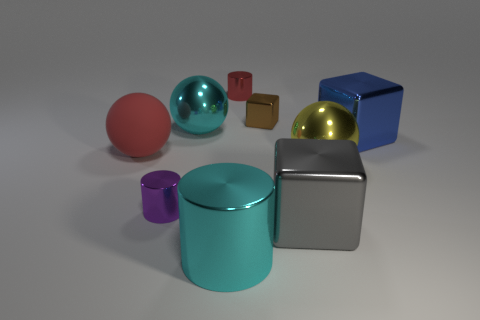Is there any other thing that has the same material as the large red sphere?
Provide a succinct answer. No. Are there fewer tiny objects that are in front of the tiny red cylinder than metallic objects in front of the yellow object?
Make the answer very short. Yes. What shape is the big metal thing that is both behind the purple cylinder and in front of the large red matte object?
Keep it short and to the point. Sphere. What number of big gray metal objects are the same shape as the small brown metallic thing?
Offer a very short reply. 1. There is a blue block that is made of the same material as the large gray cube; what is its size?
Make the answer very short. Large. What number of metallic balls have the same size as the cyan cylinder?
Offer a very short reply. 2. There is a metal sphere that is the same color as the large cylinder; what size is it?
Provide a short and direct response. Large. What color is the small object that is right of the tiny cylinder to the right of the small purple shiny thing?
Offer a terse response. Brown. Is there a large thing that has the same color as the big cylinder?
Keep it short and to the point. Yes. There is a metal cube that is the same size as the red cylinder; what is its color?
Offer a very short reply. Brown. 